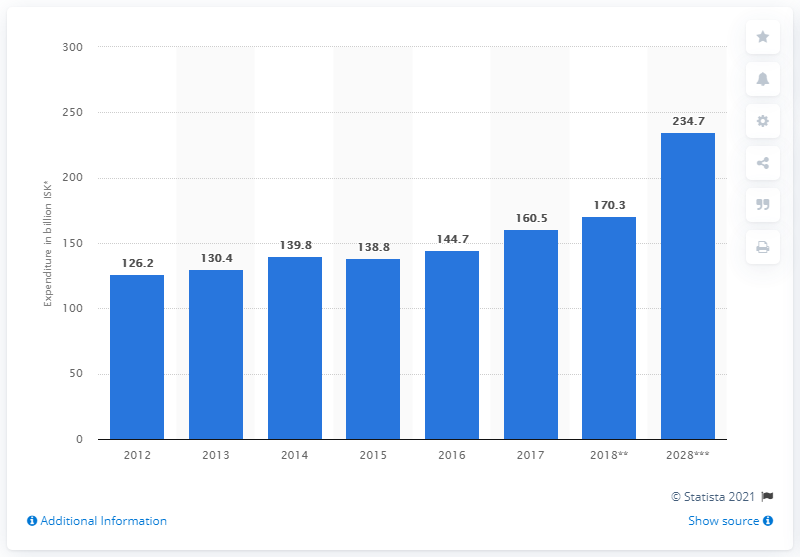Specify some key components in this picture. Domestic expenditure in Iceland is expected to reach a total of 170.3 Icelandic kr3na in 2018. 